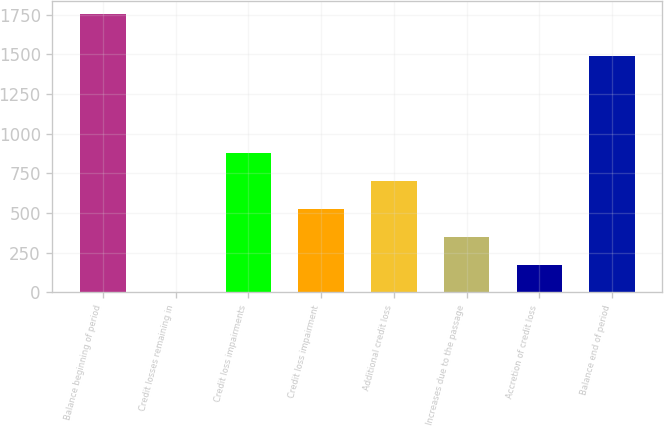Convert chart. <chart><loc_0><loc_0><loc_500><loc_500><bar_chart><fcel>Balance beginning of period<fcel>Credit losses remaining in<fcel>Credit loss impairments<fcel>Credit loss impairment<fcel>Additional credit loss<fcel>Increases due to the passage<fcel>Accretion of credit loss<fcel>Balance end of period<nl><fcel>1752<fcel>0.26<fcel>876.11<fcel>525.77<fcel>700.94<fcel>350.6<fcel>175.43<fcel>1493<nl></chart> 